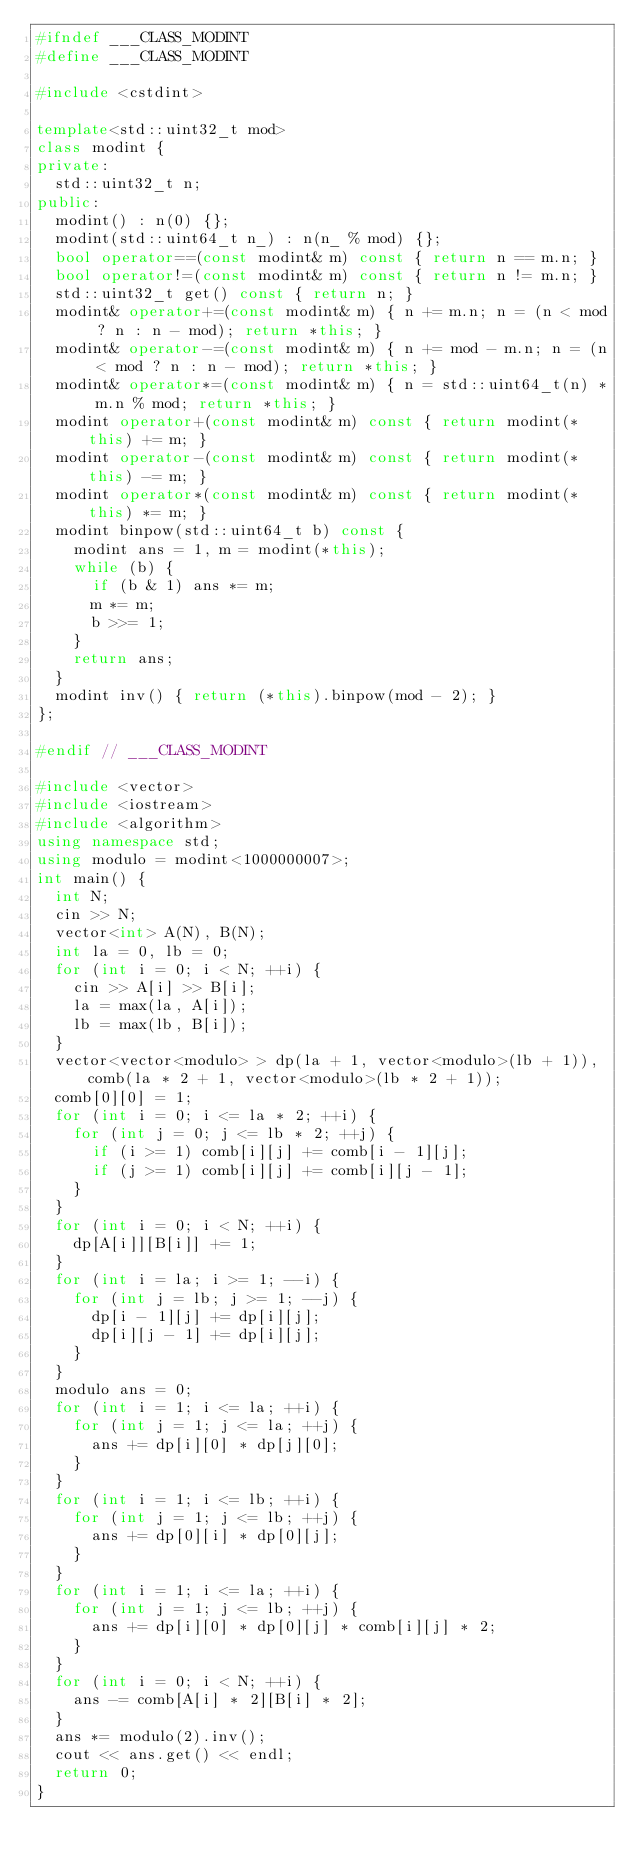<code> <loc_0><loc_0><loc_500><loc_500><_C++_>#ifndef ___CLASS_MODINT
#define ___CLASS_MODINT

#include <cstdint>

template<std::uint32_t mod>
class modint {
private:
	std::uint32_t n;
public:
	modint() : n(0) {};
	modint(std::uint64_t n_) : n(n_ % mod) {};
	bool operator==(const modint& m) const { return n == m.n; }
	bool operator!=(const modint& m) const { return n != m.n; }
	std::uint32_t get() const { return n; }
	modint& operator+=(const modint& m) { n += m.n; n = (n < mod ? n : n - mod); return *this; }
	modint& operator-=(const modint& m) { n += mod - m.n; n = (n < mod ? n : n - mod); return *this; }
	modint& operator*=(const modint& m) { n = std::uint64_t(n) * m.n % mod; return *this; }
	modint operator+(const modint& m) const { return modint(*this) += m; }
	modint operator-(const modint& m) const { return modint(*this) -= m; }
	modint operator*(const modint& m) const { return modint(*this) *= m; }
	modint binpow(std::uint64_t b) const {
		modint ans = 1, m = modint(*this);
		while (b) {
			if (b & 1) ans *= m;
			m *= m;
			b >>= 1;
		}
		return ans;
	}
	modint inv() { return (*this).binpow(mod - 2); }
};

#endif // ___CLASS_MODINT

#include <vector>
#include <iostream>
#include <algorithm>
using namespace std;
using modulo = modint<1000000007>;
int main() {
	int N;
	cin >> N;
	vector<int> A(N), B(N);
	int la = 0, lb = 0;
	for (int i = 0; i < N; ++i) {
		cin >> A[i] >> B[i];
		la = max(la, A[i]);
		lb = max(lb, B[i]);
	}
	vector<vector<modulo> > dp(la + 1, vector<modulo>(lb + 1)), comb(la * 2 + 1, vector<modulo>(lb * 2 + 1));
	comb[0][0] = 1;
	for (int i = 0; i <= la * 2; ++i) {
		for (int j = 0; j <= lb * 2; ++j) {
			if (i >= 1) comb[i][j] += comb[i - 1][j];
			if (j >= 1) comb[i][j] += comb[i][j - 1];
		}
	}
	for (int i = 0; i < N; ++i) {
		dp[A[i]][B[i]] += 1;
	}
	for (int i = la; i >= 1; --i) {
		for (int j = lb; j >= 1; --j) {
			dp[i - 1][j] += dp[i][j];
			dp[i][j - 1] += dp[i][j];
		}
	}
	modulo ans = 0;
	for (int i = 1; i <= la; ++i) {
		for (int j = 1; j <= la; ++j) {
			ans += dp[i][0] * dp[j][0];
		}
	}
	for (int i = 1; i <= lb; ++i) {
		for (int j = 1; j <= lb; ++j) {
			ans += dp[0][i] * dp[0][j];
		}
	}
	for (int i = 1; i <= la; ++i) {
		for (int j = 1; j <= lb; ++j) {
			ans += dp[i][0] * dp[0][j] * comb[i][j] * 2;
		}
	}
	for (int i = 0; i < N; ++i) {
		ans -= comb[A[i] * 2][B[i] * 2];
	}
	ans *= modulo(2).inv();
	cout << ans.get() << endl;
	return 0;
}</code> 